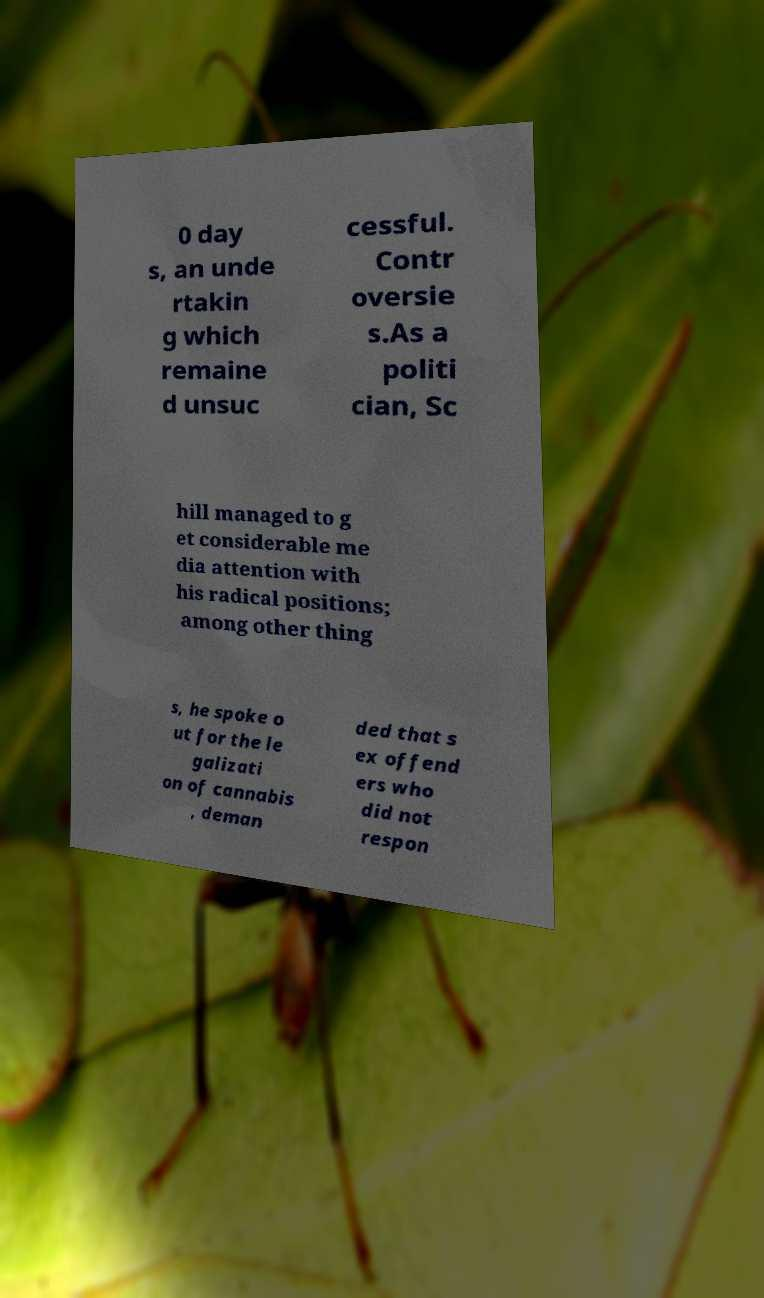I need the written content from this picture converted into text. Can you do that? 0 day s, an unde rtakin g which remaine d unsuc cessful. Contr oversie s.As a politi cian, Sc hill managed to g et considerable me dia attention with his radical positions; among other thing s, he spoke o ut for the le galizati on of cannabis , deman ded that s ex offend ers who did not respon 